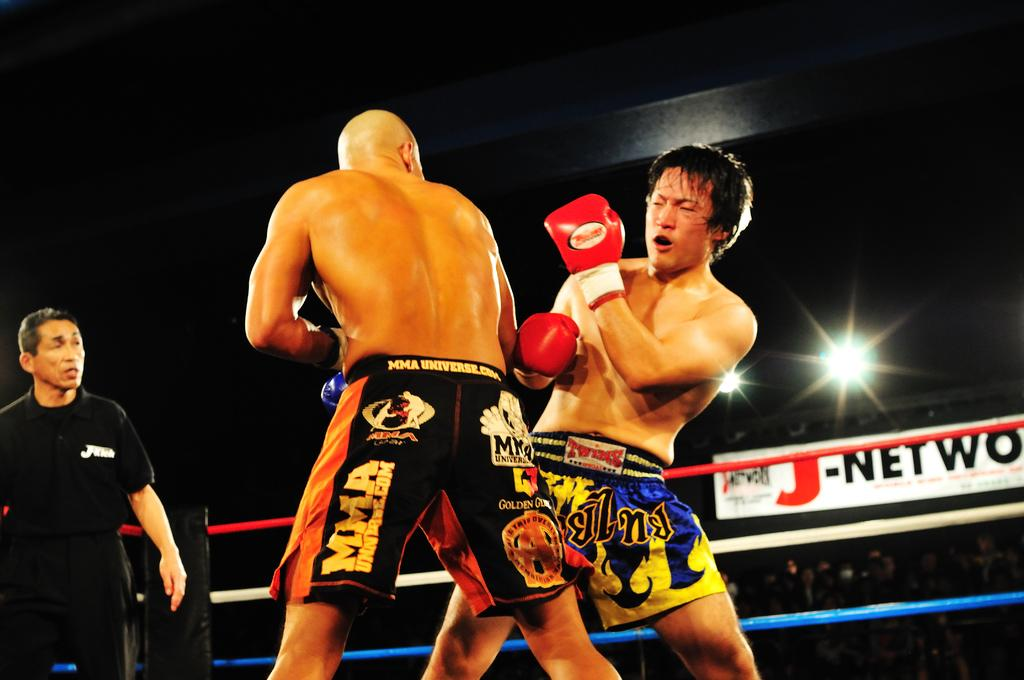<image>
Create a compact narrative representing the image presented. MMA is printed vertically in a fighter's shorts. 